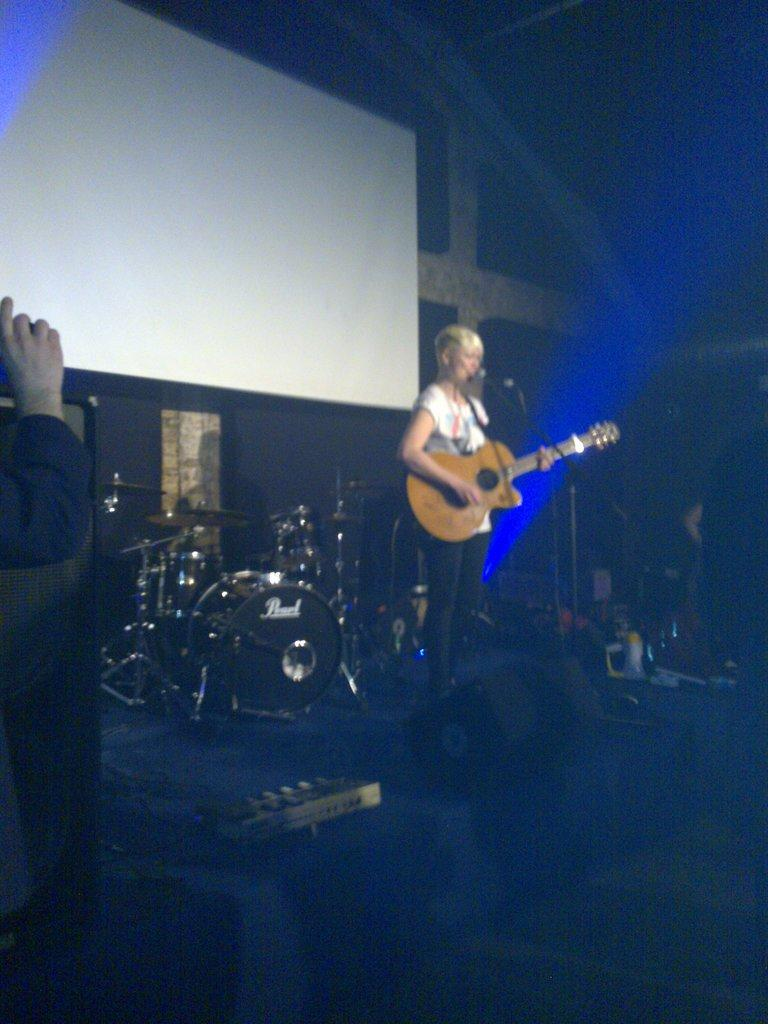What is the person in the image holding? The person is holding a guitar in the image. Can you see any other people in the image? Yes, there is a hand of another person visible in the image. What musical instrument can be seen in the background of the image? There is a drum set in the background of the image. What else is present in the background of the image? There is a screen in the background of the image. What smell can be detected coming from the guitar in the image? There is no smell associated with the guitar in the image, as it is a visual representation and not a physical object. 